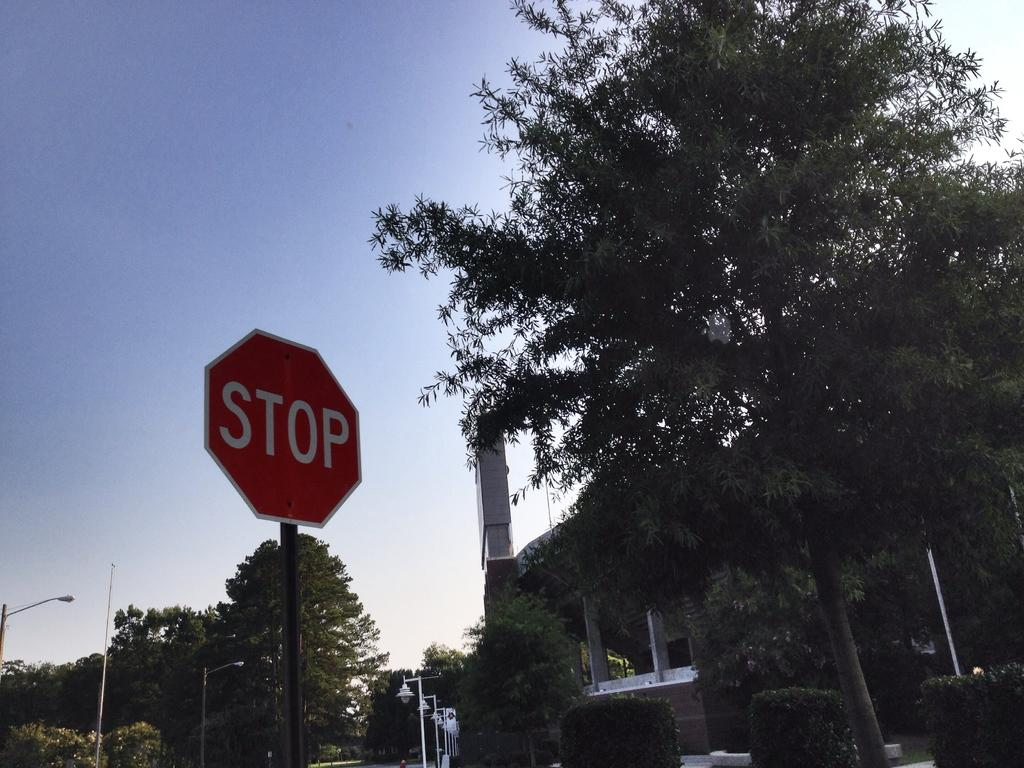What message is conveyed by the signage board in the image? The signage board indicates "stop" in the image. What type of natural elements can be seen in the image? Trees are visible in the image. What type of artificial elements can be seen in the image? There are lights in the image. What is visible in the background of the image? Trees are present in the background of the image. What type of cork can be seen in the image? There is no cork present in the image. What type of cracker is being used to signal the stop in the image? There is no cracker present in the image; the stop is indicated by a signage board. 